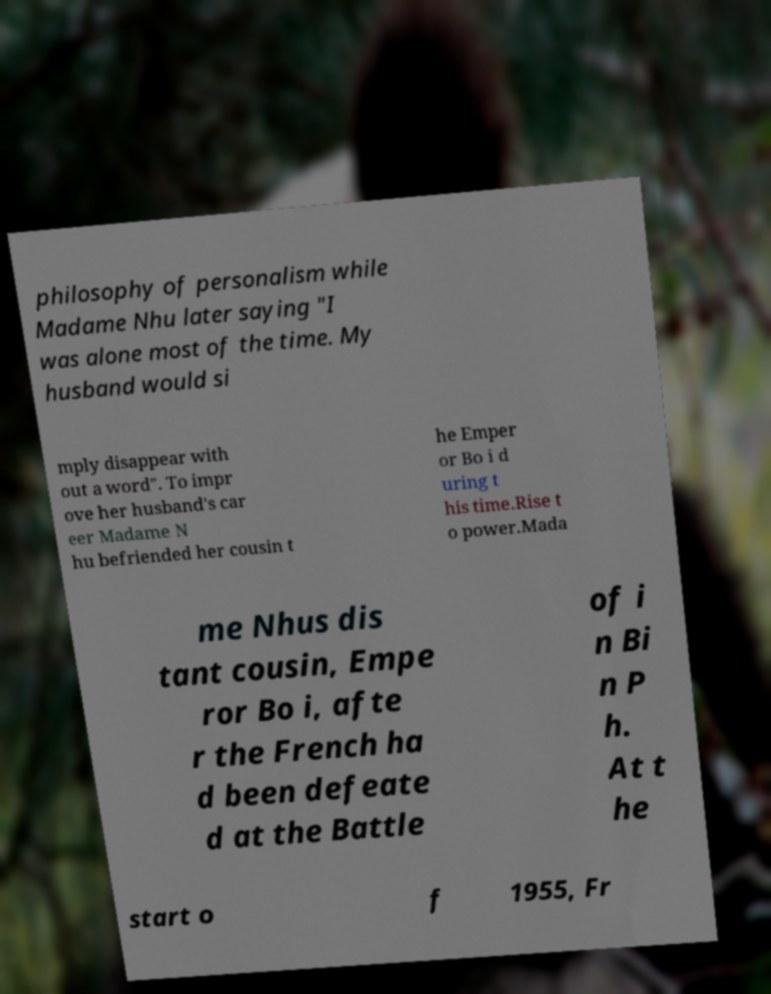I need the written content from this picture converted into text. Can you do that? philosophy of personalism while Madame Nhu later saying "I was alone most of the time. My husband would si mply disappear with out a word". To impr ove her husband's car eer Madame N hu befriended her cousin t he Emper or Bo i d uring t his time.Rise t o power.Mada me Nhus dis tant cousin, Empe ror Bo i, afte r the French ha d been defeate d at the Battle of i n Bi n P h. At t he start o f 1955, Fr 